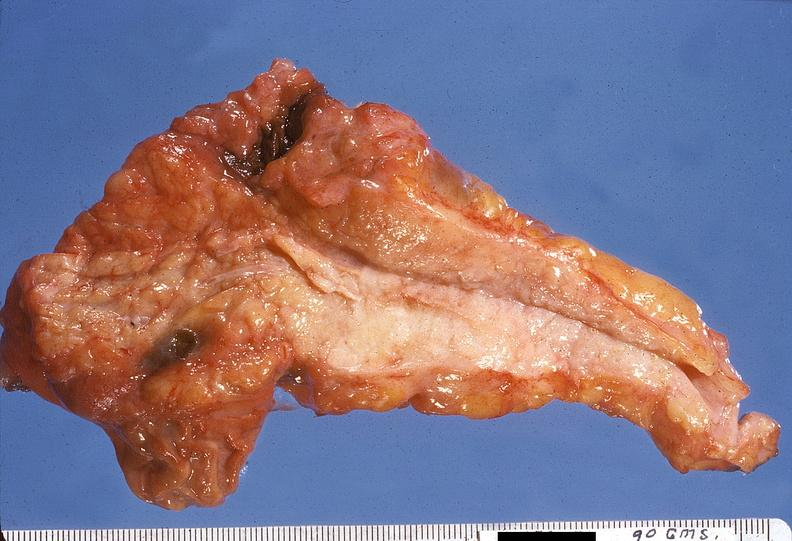what does this image show?
Answer the question using a single word or phrase. Adenocarcinoma 